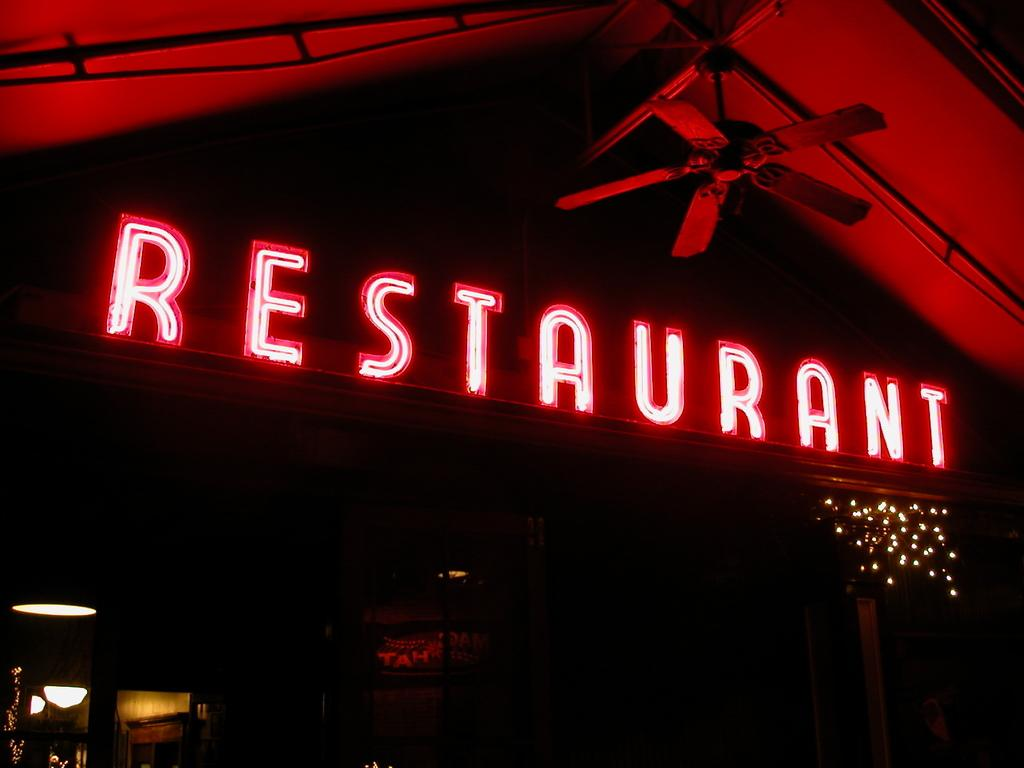What type of establishment is depicted in the image? There is a store in the image. How can the store be identified? There is a name board in the image that helps identify the store. What feature can be seen inside the store? There is a ceiling fan visible in the image. How many chairs are there in the image? There is no information about chairs in the image, so we cannot determine the number of chairs. What type of bears can be seen interacting with the ceiling fan in the image? There are no bears present in the image, and therefore no interaction with the ceiling fan can be observed. 